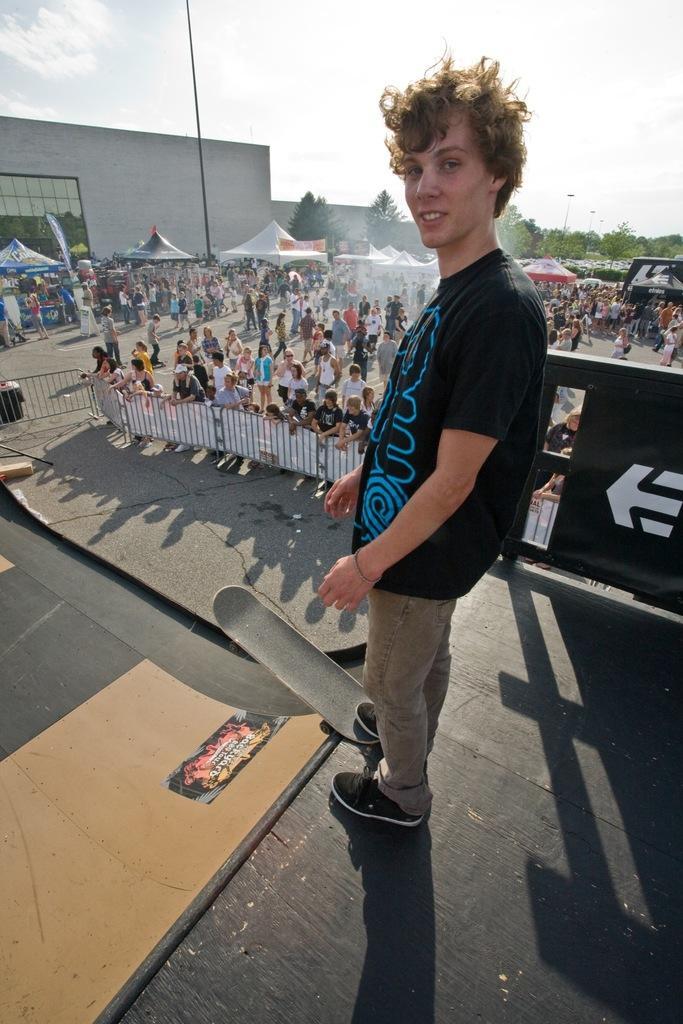Please provide a concise description of this image. In this picture we can see a man standing and smiling, skateboard, tents, trees, buildings and a group of people standing on the road and in the background we can see the sky with clouds. 